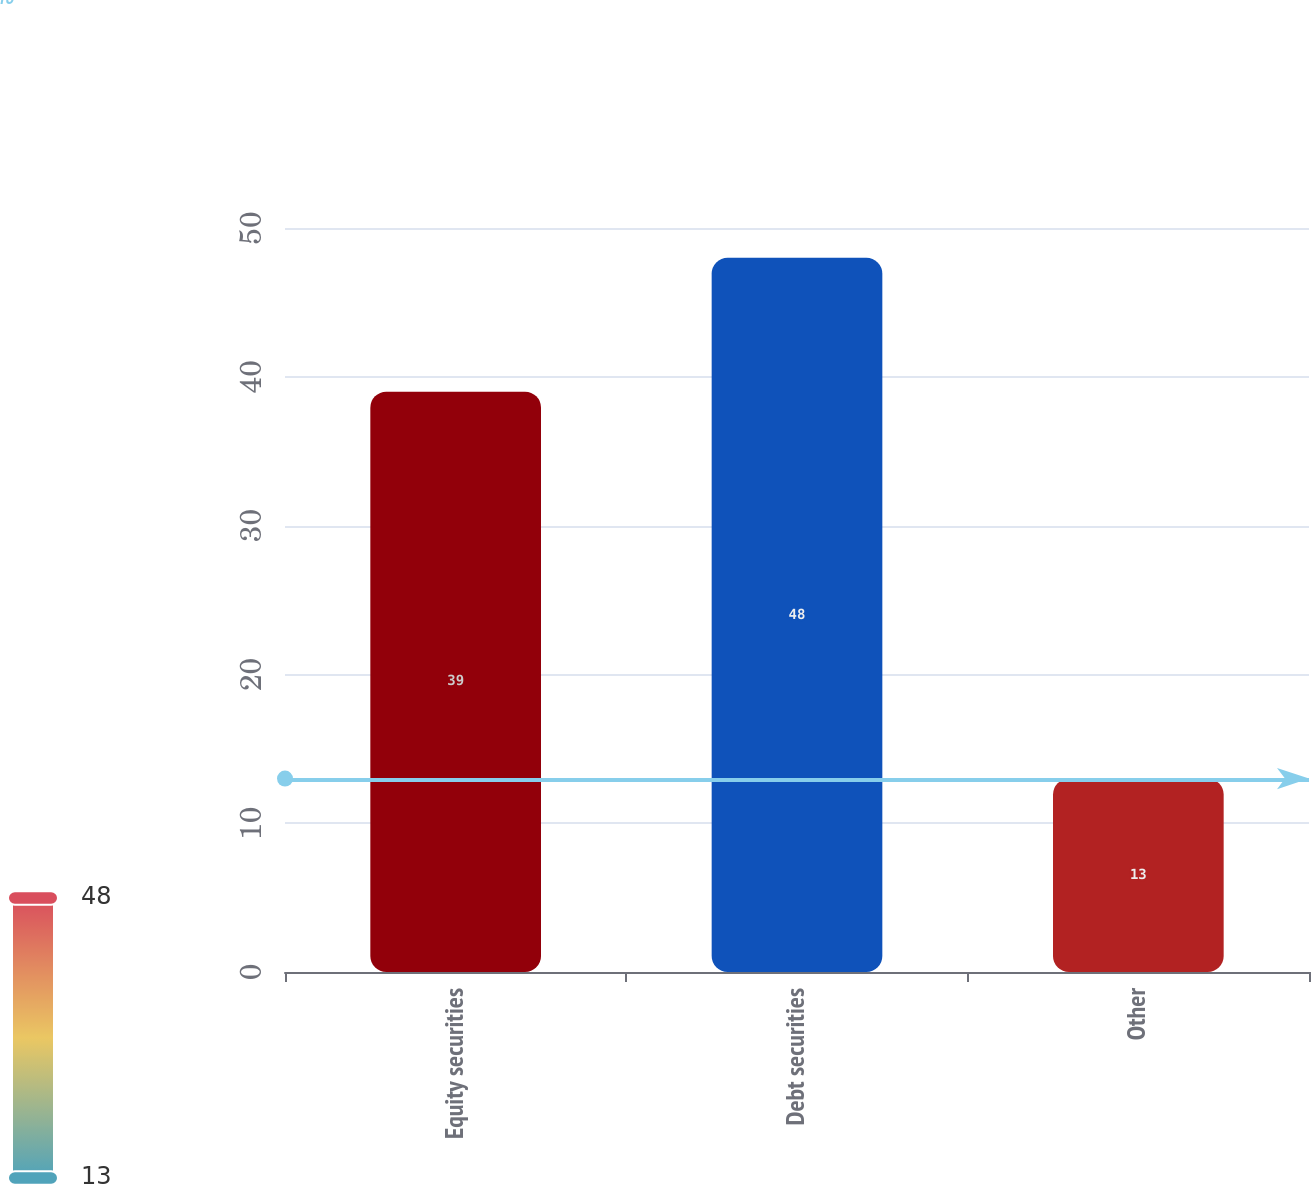<chart> <loc_0><loc_0><loc_500><loc_500><bar_chart><fcel>Equity securities<fcel>Debt securities<fcel>Other<nl><fcel>39<fcel>48<fcel>13<nl></chart> 